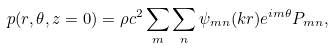<formula> <loc_0><loc_0><loc_500><loc_500>p ( r , \theta , z = 0 ) = \rho c ^ { 2 } \sum _ { m } \sum _ { n } \psi _ { m n } ( k r ) e ^ { i m \theta } P _ { m n } ,</formula> 